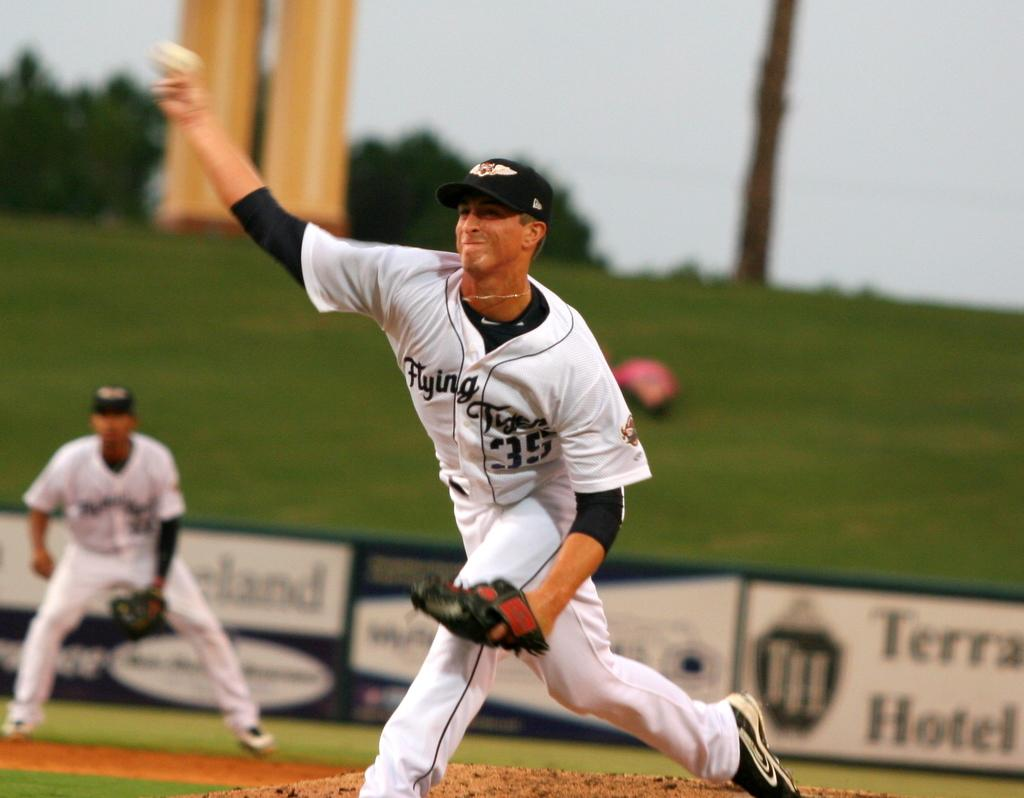Provide a one-sentence caption for the provided image. The player is wearing the number 35 Flying Tiger jersey. 